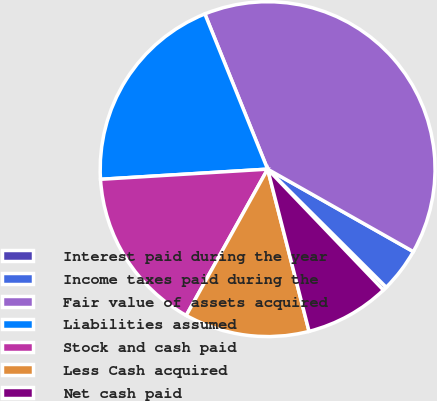<chart> <loc_0><loc_0><loc_500><loc_500><pie_chart><fcel>Interest paid during the year<fcel>Income taxes paid during the<fcel>Fair value of assets acquired<fcel>Liabilities assumed<fcel>Stock and cash paid<fcel>Less Cash acquired<fcel>Net cash paid<nl><fcel>0.38%<fcel>4.27%<fcel>39.31%<fcel>19.85%<fcel>15.95%<fcel>12.06%<fcel>8.17%<nl></chart> 